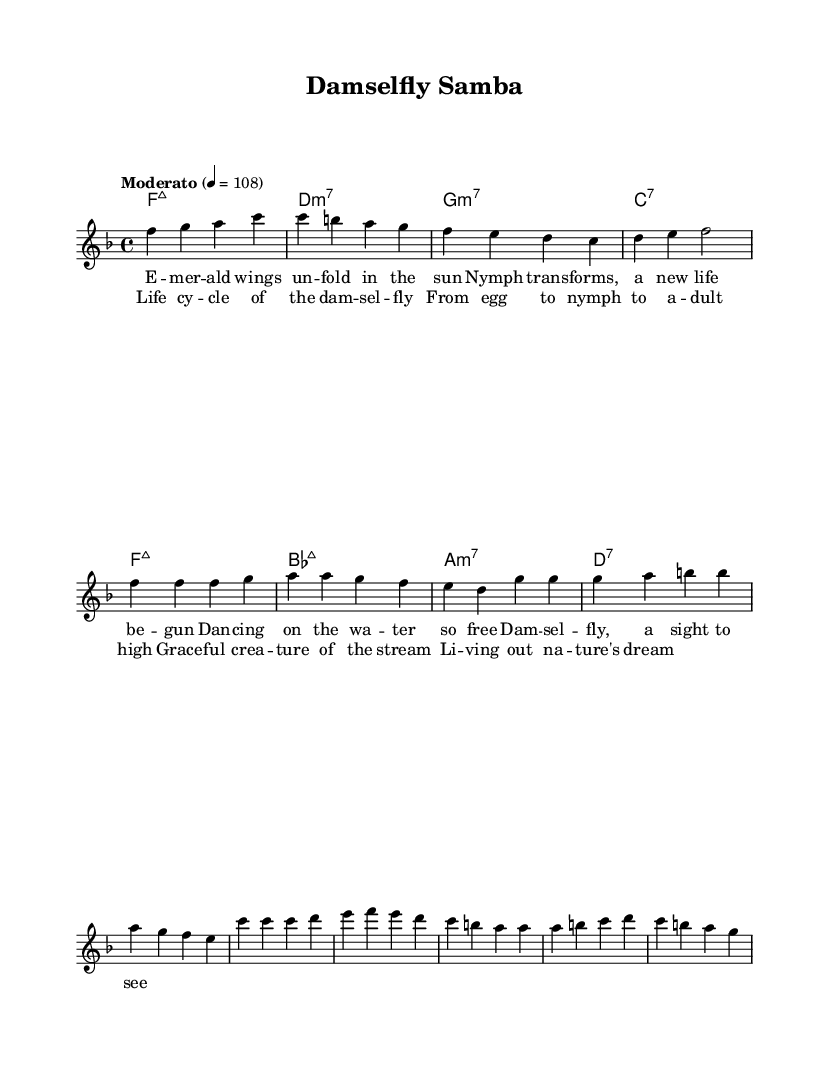What is the key signature of this music? The key signature indicated in the global settings is F major, which has one flat (B flat).
Answer: F major What is the time signature of this music? The time signature given in the global settings is 4/4, meaning there are four beats in each measure and the quarter note gets one beat.
Answer: 4/4 What is the tempo marking for this piece? The tempo is marked as "Moderato," with a metronome marking of 108 beats per minute.
Answer: Moderato How many measures are in the chorus section? The chorus comprises four measures, as indicated by the structure within the melody and lyrics.
Answer: Four measures Which chord is played in the first measure? The first measure indicates a F major 7 chord, as shown in the harmonies section.
Answer: F major 7 What does the lyric "Life cycle of the damselfly" refer to in the context of the song? This lyric encapsulates the main theme of the song, which describes the life stages of damselflies throughout the lyrics of the chorus.
Answer: Life stages What is the mood suggested by the tempo and rhythm of the piece? The moderato tempo and flowing melodies suggest a light, graceful, and reflective mood, common in bossa nova songs.
Answer: Graceful 